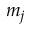<formula> <loc_0><loc_0><loc_500><loc_500>m _ { j }</formula> 